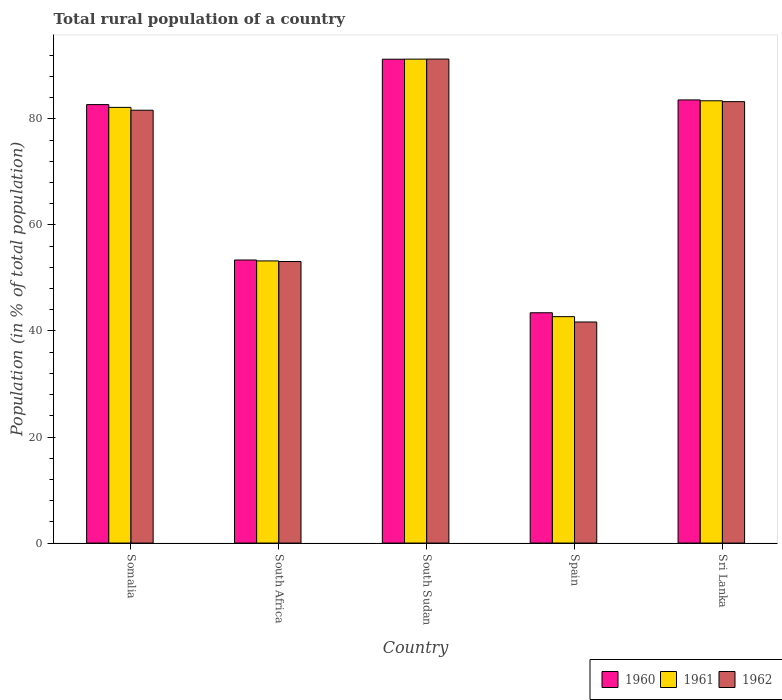How many different coloured bars are there?
Make the answer very short. 3. How many groups of bars are there?
Your response must be concise. 5. Are the number of bars per tick equal to the number of legend labels?
Offer a terse response. Yes. Are the number of bars on each tick of the X-axis equal?
Provide a short and direct response. Yes. How many bars are there on the 2nd tick from the right?
Your response must be concise. 3. What is the label of the 5th group of bars from the left?
Offer a terse response. Sri Lanka. In how many cases, is the number of bars for a given country not equal to the number of legend labels?
Provide a short and direct response. 0. What is the rural population in 1960 in Somalia?
Provide a succinct answer. 82.69. Across all countries, what is the maximum rural population in 1961?
Make the answer very short. 91.26. Across all countries, what is the minimum rural population in 1961?
Your response must be concise. 42.7. In which country was the rural population in 1962 maximum?
Your response must be concise. South Sudan. What is the total rural population in 1962 in the graph?
Keep it short and to the point. 350.94. What is the difference between the rural population in 1961 in South Africa and that in Spain?
Make the answer very short. 10.51. What is the difference between the rural population in 1962 in South Africa and the rural population in 1961 in South Sudan?
Your answer should be very brief. -38.17. What is the average rural population in 1960 per country?
Offer a terse response. 70.86. What is the difference between the rural population of/in 1960 and rural population of/in 1961 in Spain?
Your response must be concise. 0.74. In how many countries, is the rural population in 1961 greater than 36 %?
Ensure brevity in your answer.  5. What is the ratio of the rural population in 1962 in Somalia to that in Spain?
Provide a short and direct response. 1.96. Is the rural population in 1962 in Spain less than that in Sri Lanka?
Give a very brief answer. Yes. What is the difference between the highest and the second highest rural population in 1961?
Ensure brevity in your answer.  -7.86. What is the difference between the highest and the lowest rural population in 1962?
Your response must be concise. 49.58. Is the sum of the rural population in 1962 in Somalia and Spain greater than the maximum rural population in 1960 across all countries?
Offer a terse response. Yes. What does the 1st bar from the left in Spain represents?
Your response must be concise. 1960. What does the 1st bar from the right in South Sudan represents?
Offer a very short reply. 1962. Is it the case that in every country, the sum of the rural population in 1960 and rural population in 1962 is greater than the rural population in 1961?
Your response must be concise. Yes. Are all the bars in the graph horizontal?
Make the answer very short. No. How many countries are there in the graph?
Offer a terse response. 5. Does the graph contain any zero values?
Provide a short and direct response. No. Does the graph contain grids?
Provide a short and direct response. No. What is the title of the graph?
Ensure brevity in your answer.  Total rural population of a country. What is the label or title of the Y-axis?
Provide a short and direct response. Population (in % of total population). What is the Population (in % of total population) of 1960 in Somalia?
Your answer should be compact. 82.69. What is the Population (in % of total population) in 1961 in Somalia?
Keep it short and to the point. 82.17. What is the Population (in % of total population) in 1962 in Somalia?
Your response must be concise. 81.63. What is the Population (in % of total population) of 1960 in South Africa?
Make the answer very short. 53.38. What is the Population (in % of total population) in 1961 in South Africa?
Your answer should be very brief. 53.21. What is the Population (in % of total population) in 1962 in South Africa?
Your answer should be compact. 53.09. What is the Population (in % of total population) in 1960 in South Sudan?
Provide a short and direct response. 91.25. What is the Population (in % of total population) of 1961 in South Sudan?
Your response must be concise. 91.26. What is the Population (in % of total population) of 1962 in South Sudan?
Your answer should be compact. 91.28. What is the Population (in % of total population) of 1960 in Spain?
Keep it short and to the point. 43.43. What is the Population (in % of total population) in 1961 in Spain?
Offer a terse response. 42.7. What is the Population (in % of total population) in 1962 in Spain?
Provide a short and direct response. 41.69. What is the Population (in % of total population) of 1960 in Sri Lanka?
Provide a short and direct response. 83.57. What is the Population (in % of total population) in 1961 in Sri Lanka?
Offer a terse response. 83.41. What is the Population (in % of total population) in 1962 in Sri Lanka?
Keep it short and to the point. 83.25. Across all countries, what is the maximum Population (in % of total population) of 1960?
Keep it short and to the point. 91.25. Across all countries, what is the maximum Population (in % of total population) of 1961?
Provide a short and direct response. 91.26. Across all countries, what is the maximum Population (in % of total population) in 1962?
Keep it short and to the point. 91.28. Across all countries, what is the minimum Population (in % of total population) in 1960?
Keep it short and to the point. 43.43. Across all countries, what is the minimum Population (in % of total population) of 1961?
Give a very brief answer. 42.7. Across all countries, what is the minimum Population (in % of total population) of 1962?
Offer a very short reply. 41.69. What is the total Population (in % of total population) in 1960 in the graph?
Provide a succinct answer. 354.32. What is the total Population (in % of total population) in 1961 in the graph?
Ensure brevity in your answer.  352.74. What is the total Population (in % of total population) of 1962 in the graph?
Ensure brevity in your answer.  350.94. What is the difference between the Population (in % of total population) of 1960 in Somalia and that in South Africa?
Your answer should be very brief. 29.31. What is the difference between the Population (in % of total population) of 1961 in Somalia and that in South Africa?
Your response must be concise. 28.96. What is the difference between the Population (in % of total population) in 1962 in Somalia and that in South Africa?
Your answer should be compact. 28.53. What is the difference between the Population (in % of total population) in 1960 in Somalia and that in South Sudan?
Ensure brevity in your answer.  -8.56. What is the difference between the Population (in % of total population) in 1961 in Somalia and that in South Sudan?
Your answer should be very brief. -9.1. What is the difference between the Population (in % of total population) in 1962 in Somalia and that in South Sudan?
Keep it short and to the point. -9.65. What is the difference between the Population (in % of total population) of 1960 in Somalia and that in Spain?
Your answer should be very brief. 39.26. What is the difference between the Population (in % of total population) in 1961 in Somalia and that in Spain?
Keep it short and to the point. 39.47. What is the difference between the Population (in % of total population) in 1962 in Somalia and that in Spain?
Give a very brief answer. 39.94. What is the difference between the Population (in % of total population) in 1960 in Somalia and that in Sri Lanka?
Provide a short and direct response. -0.88. What is the difference between the Population (in % of total population) of 1961 in Somalia and that in Sri Lanka?
Make the answer very short. -1.24. What is the difference between the Population (in % of total population) in 1962 in Somalia and that in Sri Lanka?
Keep it short and to the point. -1.62. What is the difference between the Population (in % of total population) in 1960 in South Africa and that in South Sudan?
Ensure brevity in your answer.  -37.87. What is the difference between the Population (in % of total population) in 1961 in South Africa and that in South Sudan?
Make the answer very short. -38.06. What is the difference between the Population (in % of total population) of 1962 in South Africa and that in South Sudan?
Offer a very short reply. -38.18. What is the difference between the Population (in % of total population) in 1960 in South Africa and that in Spain?
Provide a short and direct response. 9.95. What is the difference between the Population (in % of total population) in 1961 in South Africa and that in Spain?
Ensure brevity in your answer.  10.51. What is the difference between the Population (in % of total population) of 1962 in South Africa and that in Spain?
Keep it short and to the point. 11.4. What is the difference between the Population (in % of total population) of 1960 in South Africa and that in Sri Lanka?
Your response must be concise. -30.19. What is the difference between the Population (in % of total population) of 1961 in South Africa and that in Sri Lanka?
Provide a short and direct response. -30.2. What is the difference between the Population (in % of total population) in 1962 in South Africa and that in Sri Lanka?
Offer a terse response. -30.15. What is the difference between the Population (in % of total population) of 1960 in South Sudan and that in Spain?
Offer a very short reply. 47.82. What is the difference between the Population (in % of total population) in 1961 in South Sudan and that in Spain?
Ensure brevity in your answer.  48.57. What is the difference between the Population (in % of total population) of 1962 in South Sudan and that in Spain?
Keep it short and to the point. 49.58. What is the difference between the Population (in % of total population) of 1960 in South Sudan and that in Sri Lanka?
Your answer should be very brief. 7.68. What is the difference between the Population (in % of total population) in 1961 in South Sudan and that in Sri Lanka?
Keep it short and to the point. 7.86. What is the difference between the Population (in % of total population) in 1962 in South Sudan and that in Sri Lanka?
Your response must be concise. 8.03. What is the difference between the Population (in % of total population) in 1960 in Spain and that in Sri Lanka?
Offer a terse response. -40.14. What is the difference between the Population (in % of total population) in 1961 in Spain and that in Sri Lanka?
Your answer should be compact. -40.71. What is the difference between the Population (in % of total population) of 1962 in Spain and that in Sri Lanka?
Provide a short and direct response. -41.55. What is the difference between the Population (in % of total population) of 1960 in Somalia and the Population (in % of total population) of 1961 in South Africa?
Your answer should be very brief. 29.48. What is the difference between the Population (in % of total population) in 1960 in Somalia and the Population (in % of total population) in 1962 in South Africa?
Provide a succinct answer. 29.59. What is the difference between the Population (in % of total population) in 1961 in Somalia and the Population (in % of total population) in 1962 in South Africa?
Your response must be concise. 29.07. What is the difference between the Population (in % of total population) of 1960 in Somalia and the Population (in % of total population) of 1961 in South Sudan?
Provide a short and direct response. -8.57. What is the difference between the Population (in % of total population) in 1960 in Somalia and the Population (in % of total population) in 1962 in South Sudan?
Give a very brief answer. -8.59. What is the difference between the Population (in % of total population) of 1961 in Somalia and the Population (in % of total population) of 1962 in South Sudan?
Make the answer very short. -9.11. What is the difference between the Population (in % of total population) of 1960 in Somalia and the Population (in % of total population) of 1961 in Spain?
Your answer should be compact. 39.99. What is the difference between the Population (in % of total population) of 1960 in Somalia and the Population (in % of total population) of 1962 in Spain?
Provide a short and direct response. 41. What is the difference between the Population (in % of total population) of 1961 in Somalia and the Population (in % of total population) of 1962 in Spain?
Your answer should be very brief. 40.47. What is the difference between the Population (in % of total population) in 1960 in Somalia and the Population (in % of total population) in 1961 in Sri Lanka?
Give a very brief answer. -0.72. What is the difference between the Population (in % of total population) in 1960 in Somalia and the Population (in % of total population) in 1962 in Sri Lanka?
Ensure brevity in your answer.  -0.56. What is the difference between the Population (in % of total population) of 1961 in Somalia and the Population (in % of total population) of 1962 in Sri Lanka?
Offer a terse response. -1.08. What is the difference between the Population (in % of total population) of 1960 in South Africa and the Population (in % of total population) of 1961 in South Sudan?
Offer a very short reply. -37.88. What is the difference between the Population (in % of total population) in 1960 in South Africa and the Population (in % of total population) in 1962 in South Sudan?
Give a very brief answer. -37.89. What is the difference between the Population (in % of total population) in 1961 in South Africa and the Population (in % of total population) in 1962 in South Sudan?
Your answer should be compact. -38.07. What is the difference between the Population (in % of total population) of 1960 in South Africa and the Population (in % of total population) of 1961 in Spain?
Make the answer very short. 10.68. What is the difference between the Population (in % of total population) of 1960 in South Africa and the Population (in % of total population) of 1962 in Spain?
Your response must be concise. 11.69. What is the difference between the Population (in % of total population) of 1961 in South Africa and the Population (in % of total population) of 1962 in Spain?
Offer a terse response. 11.52. What is the difference between the Population (in % of total population) in 1960 in South Africa and the Population (in % of total population) in 1961 in Sri Lanka?
Ensure brevity in your answer.  -30.03. What is the difference between the Population (in % of total population) of 1960 in South Africa and the Population (in % of total population) of 1962 in Sri Lanka?
Your response must be concise. -29.87. What is the difference between the Population (in % of total population) of 1961 in South Africa and the Population (in % of total population) of 1962 in Sri Lanka?
Make the answer very short. -30.04. What is the difference between the Population (in % of total population) of 1960 in South Sudan and the Population (in % of total population) of 1961 in Spain?
Your answer should be compact. 48.55. What is the difference between the Population (in % of total population) in 1960 in South Sudan and the Population (in % of total population) in 1962 in Spain?
Keep it short and to the point. 49.56. What is the difference between the Population (in % of total population) in 1961 in South Sudan and the Population (in % of total population) in 1962 in Spain?
Your answer should be very brief. 49.57. What is the difference between the Population (in % of total population) in 1960 in South Sudan and the Population (in % of total population) in 1961 in Sri Lanka?
Your response must be concise. 7.84. What is the difference between the Population (in % of total population) of 1960 in South Sudan and the Population (in % of total population) of 1962 in Sri Lanka?
Provide a short and direct response. 8.01. What is the difference between the Population (in % of total population) in 1961 in South Sudan and the Population (in % of total population) in 1962 in Sri Lanka?
Provide a short and direct response. 8.02. What is the difference between the Population (in % of total population) of 1960 in Spain and the Population (in % of total population) of 1961 in Sri Lanka?
Your answer should be very brief. -39.98. What is the difference between the Population (in % of total population) of 1960 in Spain and the Population (in % of total population) of 1962 in Sri Lanka?
Offer a terse response. -39.81. What is the difference between the Population (in % of total population) of 1961 in Spain and the Population (in % of total population) of 1962 in Sri Lanka?
Provide a short and direct response. -40.55. What is the average Population (in % of total population) in 1960 per country?
Your answer should be compact. 70.86. What is the average Population (in % of total population) of 1961 per country?
Make the answer very short. 70.55. What is the average Population (in % of total population) of 1962 per country?
Provide a succinct answer. 70.19. What is the difference between the Population (in % of total population) in 1960 and Population (in % of total population) in 1961 in Somalia?
Your answer should be compact. 0.52. What is the difference between the Population (in % of total population) in 1960 and Population (in % of total population) in 1962 in Somalia?
Offer a very short reply. 1.06. What is the difference between the Population (in % of total population) of 1961 and Population (in % of total population) of 1962 in Somalia?
Offer a very short reply. 0.54. What is the difference between the Population (in % of total population) of 1960 and Population (in % of total population) of 1961 in South Africa?
Keep it short and to the point. 0.17. What is the difference between the Population (in % of total population) of 1960 and Population (in % of total population) of 1962 in South Africa?
Ensure brevity in your answer.  0.29. What is the difference between the Population (in % of total population) of 1961 and Population (in % of total population) of 1962 in South Africa?
Give a very brief answer. 0.11. What is the difference between the Population (in % of total population) in 1960 and Population (in % of total population) in 1961 in South Sudan?
Offer a terse response. -0.01. What is the difference between the Population (in % of total population) in 1960 and Population (in % of total population) in 1962 in South Sudan?
Keep it short and to the point. -0.02. What is the difference between the Population (in % of total population) of 1961 and Population (in % of total population) of 1962 in South Sudan?
Give a very brief answer. -0.01. What is the difference between the Population (in % of total population) in 1960 and Population (in % of total population) in 1961 in Spain?
Provide a succinct answer. 0.74. What is the difference between the Population (in % of total population) of 1960 and Population (in % of total population) of 1962 in Spain?
Provide a short and direct response. 1.74. What is the difference between the Population (in % of total population) in 1961 and Population (in % of total population) in 1962 in Spain?
Give a very brief answer. 1. What is the difference between the Population (in % of total population) of 1960 and Population (in % of total population) of 1961 in Sri Lanka?
Ensure brevity in your answer.  0.16. What is the difference between the Population (in % of total population) of 1960 and Population (in % of total population) of 1962 in Sri Lanka?
Your answer should be compact. 0.32. What is the difference between the Population (in % of total population) in 1961 and Population (in % of total population) in 1962 in Sri Lanka?
Offer a very short reply. 0.16. What is the ratio of the Population (in % of total population) of 1960 in Somalia to that in South Africa?
Ensure brevity in your answer.  1.55. What is the ratio of the Population (in % of total population) of 1961 in Somalia to that in South Africa?
Your response must be concise. 1.54. What is the ratio of the Population (in % of total population) in 1962 in Somalia to that in South Africa?
Keep it short and to the point. 1.54. What is the ratio of the Population (in % of total population) of 1960 in Somalia to that in South Sudan?
Offer a very short reply. 0.91. What is the ratio of the Population (in % of total population) of 1961 in Somalia to that in South Sudan?
Offer a terse response. 0.9. What is the ratio of the Population (in % of total population) in 1962 in Somalia to that in South Sudan?
Keep it short and to the point. 0.89. What is the ratio of the Population (in % of total population) of 1960 in Somalia to that in Spain?
Provide a succinct answer. 1.9. What is the ratio of the Population (in % of total population) of 1961 in Somalia to that in Spain?
Offer a terse response. 1.92. What is the ratio of the Population (in % of total population) in 1962 in Somalia to that in Spain?
Ensure brevity in your answer.  1.96. What is the ratio of the Population (in % of total population) of 1960 in Somalia to that in Sri Lanka?
Give a very brief answer. 0.99. What is the ratio of the Population (in % of total population) of 1961 in Somalia to that in Sri Lanka?
Ensure brevity in your answer.  0.99. What is the ratio of the Population (in % of total population) of 1962 in Somalia to that in Sri Lanka?
Ensure brevity in your answer.  0.98. What is the ratio of the Population (in % of total population) in 1960 in South Africa to that in South Sudan?
Ensure brevity in your answer.  0.58. What is the ratio of the Population (in % of total population) of 1961 in South Africa to that in South Sudan?
Offer a very short reply. 0.58. What is the ratio of the Population (in % of total population) in 1962 in South Africa to that in South Sudan?
Your answer should be compact. 0.58. What is the ratio of the Population (in % of total population) of 1960 in South Africa to that in Spain?
Make the answer very short. 1.23. What is the ratio of the Population (in % of total population) of 1961 in South Africa to that in Spain?
Offer a terse response. 1.25. What is the ratio of the Population (in % of total population) of 1962 in South Africa to that in Spain?
Ensure brevity in your answer.  1.27. What is the ratio of the Population (in % of total population) of 1960 in South Africa to that in Sri Lanka?
Make the answer very short. 0.64. What is the ratio of the Population (in % of total population) in 1961 in South Africa to that in Sri Lanka?
Provide a succinct answer. 0.64. What is the ratio of the Population (in % of total population) of 1962 in South Africa to that in Sri Lanka?
Give a very brief answer. 0.64. What is the ratio of the Population (in % of total population) of 1960 in South Sudan to that in Spain?
Give a very brief answer. 2.1. What is the ratio of the Population (in % of total population) in 1961 in South Sudan to that in Spain?
Ensure brevity in your answer.  2.14. What is the ratio of the Population (in % of total population) of 1962 in South Sudan to that in Spain?
Keep it short and to the point. 2.19. What is the ratio of the Population (in % of total population) in 1960 in South Sudan to that in Sri Lanka?
Offer a very short reply. 1.09. What is the ratio of the Population (in % of total population) of 1961 in South Sudan to that in Sri Lanka?
Give a very brief answer. 1.09. What is the ratio of the Population (in % of total population) in 1962 in South Sudan to that in Sri Lanka?
Ensure brevity in your answer.  1.1. What is the ratio of the Population (in % of total population) in 1960 in Spain to that in Sri Lanka?
Your response must be concise. 0.52. What is the ratio of the Population (in % of total population) in 1961 in Spain to that in Sri Lanka?
Provide a short and direct response. 0.51. What is the ratio of the Population (in % of total population) of 1962 in Spain to that in Sri Lanka?
Offer a terse response. 0.5. What is the difference between the highest and the second highest Population (in % of total population) in 1960?
Keep it short and to the point. 7.68. What is the difference between the highest and the second highest Population (in % of total population) in 1961?
Keep it short and to the point. 7.86. What is the difference between the highest and the second highest Population (in % of total population) of 1962?
Make the answer very short. 8.03. What is the difference between the highest and the lowest Population (in % of total population) of 1960?
Your response must be concise. 47.82. What is the difference between the highest and the lowest Population (in % of total population) in 1961?
Offer a very short reply. 48.57. What is the difference between the highest and the lowest Population (in % of total population) in 1962?
Give a very brief answer. 49.58. 